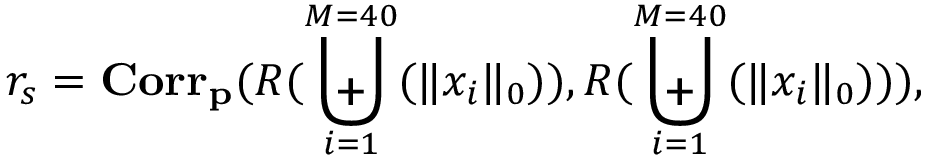<formula> <loc_0><loc_0><loc_500><loc_500>r _ { s } = C o r r _ { p } ( R ( \Big u p l u s _ { i = 1 } ^ { M = 4 0 } ( \| x _ { i } \| _ { 0 } ) ) , R ( \Big u p l u s _ { i = 1 } ^ { M = 4 0 } ( \| x _ { i } \| _ { 0 } ) ) ) ,</formula> 